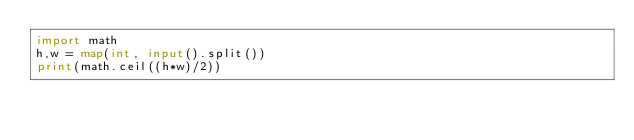Convert code to text. <code><loc_0><loc_0><loc_500><loc_500><_Python_>import math
h,w = map(int, input().split())
print(math.ceil((h*w)/2))</code> 